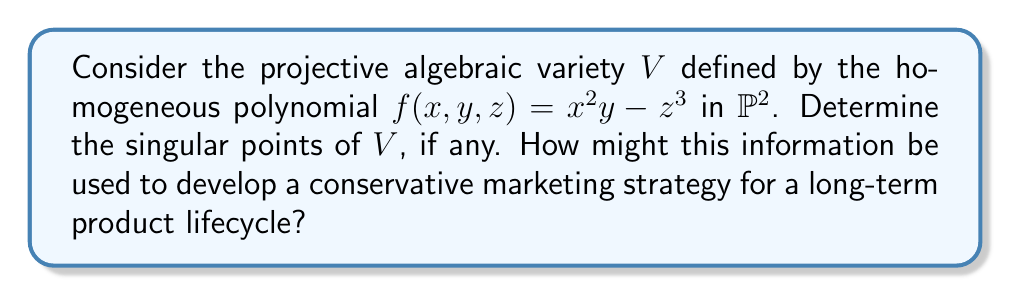Solve this math problem. To find the singular points of the projective algebraic variety $V$, we need to follow these steps:

1) First, recall that a point $P = [a:b:c]$ on $V$ is singular if all partial derivatives of $f$ vanish at $P$. 

2) Let's compute the partial derivatives:
   $$\frac{\partial f}{\partial x} = 2xy$$
   $$\frac{\partial f}{\partial y} = x^2$$
   $$\frac{\partial f}{\partial z} = -3z^2$$

3) For a point $P = [a:b:c]$ to be singular, we must have:
   $$2ab = 0$$
   $$a^2 = 0$$
   $$-3c^2 = 0$$

4) From $a^2 = 0$, we deduce that $a = 0$.

5) If $a = 0$, then the equation $f(x,y,z) = x^2y - z^3 = 0$ reduces to $-z^3 = 0$, which implies $c = 0$.

6) The only point satisfying these conditions is $P = [0:1:0]$, where we've chosen the representative with $y = 1$ since we're in projective space.

7) We can verify that this point indeed lies on $V$ by substituting it into the original equation:
   $f(0,1,0) = 0^2(1) - 0^3 = 0$

Therefore, $V$ has a single singular point at $[0:1:0]$.

From a conservative marketing perspective, this result could be used to develop a strategy that focuses on the product's stability and reliability over time. The single singular point could represent a unique selling proposition or a key feature that distinguishes the product in the market. By emphasizing this "singular" aspect, the marketing team could build a long-term campaign around the product's consistency and dependability, appealing to customers who value tried-and-true solutions over rapidly changing alternatives.
Answer: $[0:1:0]$ 